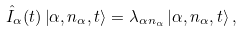<formula> <loc_0><loc_0><loc_500><loc_500>\hat { I } _ { \alpha } ( t ) \left | \alpha , n _ { \alpha } , t \right > = \lambda _ { \alpha n _ { \alpha } } \left | \alpha , n _ { \alpha } , t \right > ,</formula> 